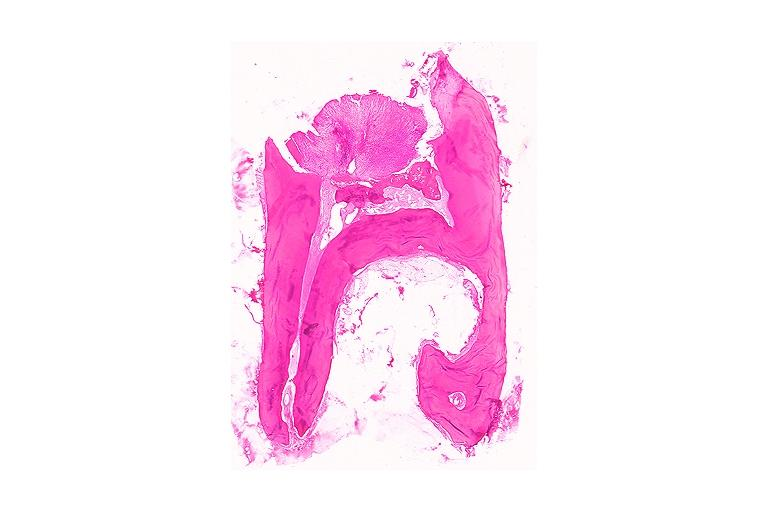does lip show chronic hyperplastic pulpitis?
Answer the question using a single word or phrase. No 